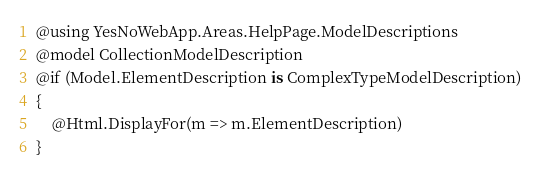<code> <loc_0><loc_0><loc_500><loc_500><_C#_>@using YesNoWebApp.Areas.HelpPage.ModelDescriptions
@model CollectionModelDescription
@if (Model.ElementDescription is ComplexTypeModelDescription)
{
    @Html.DisplayFor(m => m.ElementDescription)
}</code> 